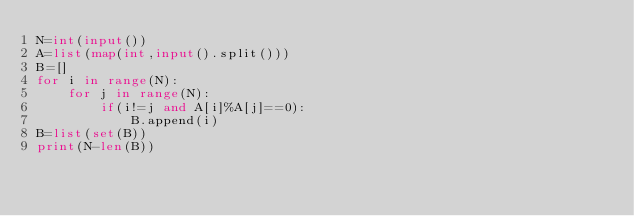<code> <loc_0><loc_0><loc_500><loc_500><_Python_>N=int(input())
A=list(map(int,input().split()))
B=[]
for i in range(N):
    for j in range(N):
        if(i!=j and A[i]%A[j]==0):
            B.append(i)
B=list(set(B))
print(N-len(B))</code> 